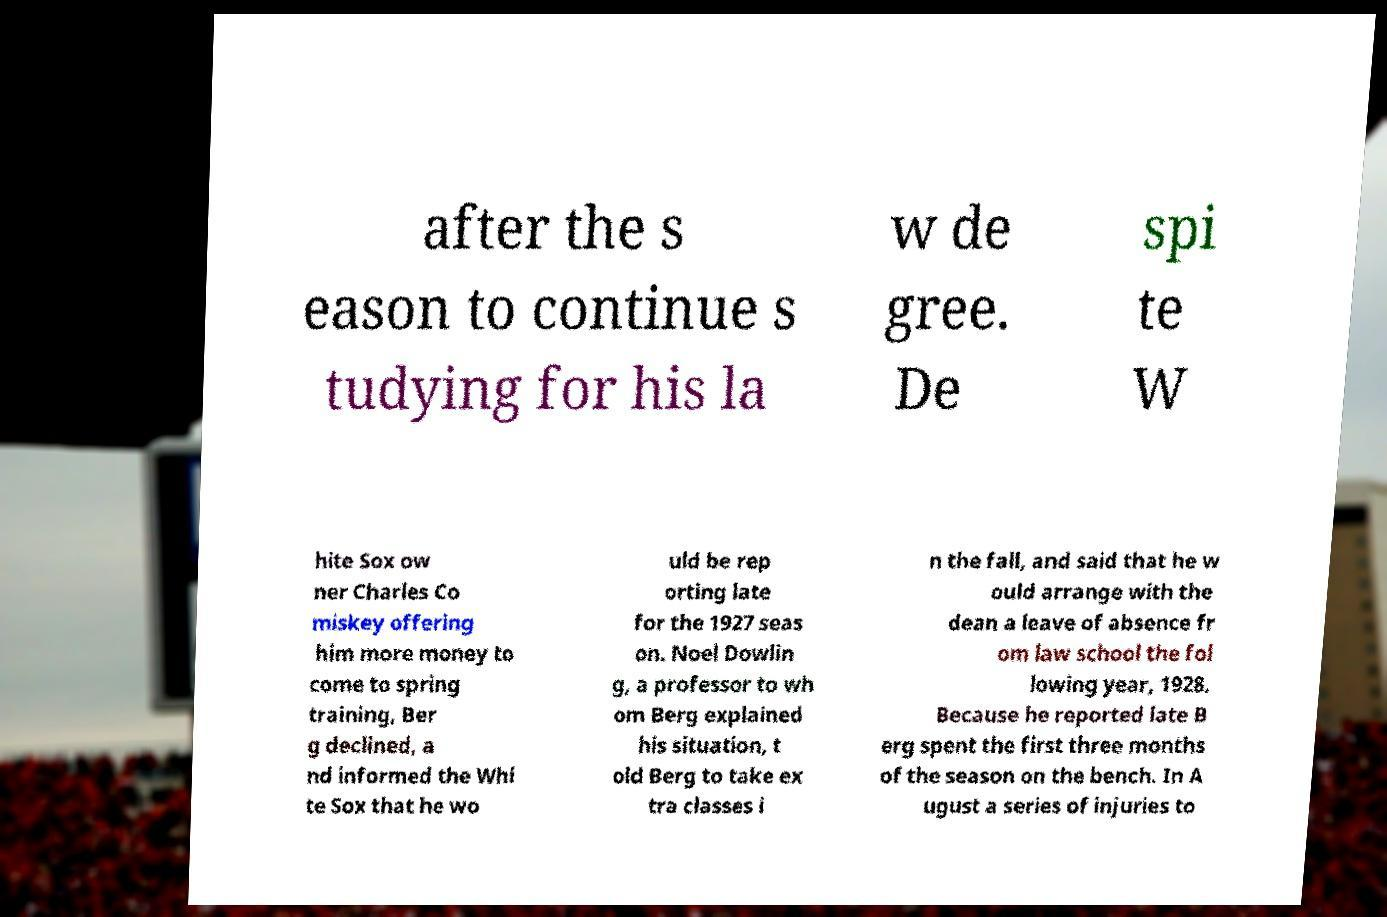Could you extract and type out the text from this image? after the s eason to continue s tudying for his la w de gree. De spi te W hite Sox ow ner Charles Co miskey offering him more money to come to spring training, Ber g declined, a nd informed the Whi te Sox that he wo uld be rep orting late for the 1927 seas on. Noel Dowlin g, a professor to wh om Berg explained his situation, t old Berg to take ex tra classes i n the fall, and said that he w ould arrange with the dean a leave of absence fr om law school the fol lowing year, 1928. Because he reported late B erg spent the first three months of the season on the bench. In A ugust a series of injuries to 